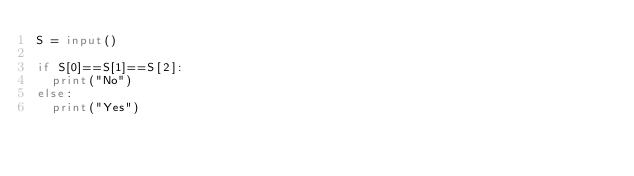<code> <loc_0><loc_0><loc_500><loc_500><_Python_>S = input()

if S[0]==S[1]==S[2]:
  print("No")
else:
  print("Yes")</code> 